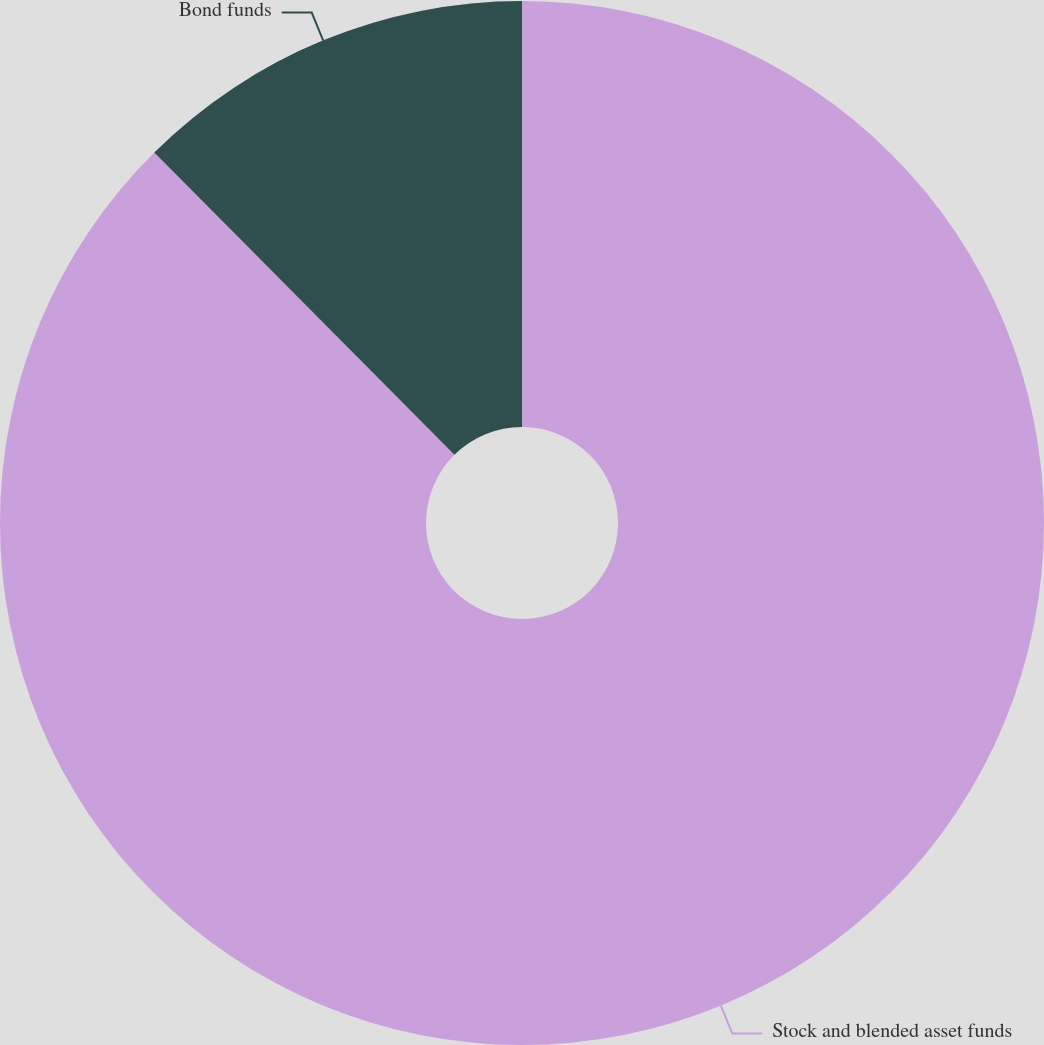Convert chart to OTSL. <chart><loc_0><loc_0><loc_500><loc_500><pie_chart><fcel>Stock and blended asset funds<fcel>Bond funds<nl><fcel>87.56%<fcel>12.44%<nl></chart> 